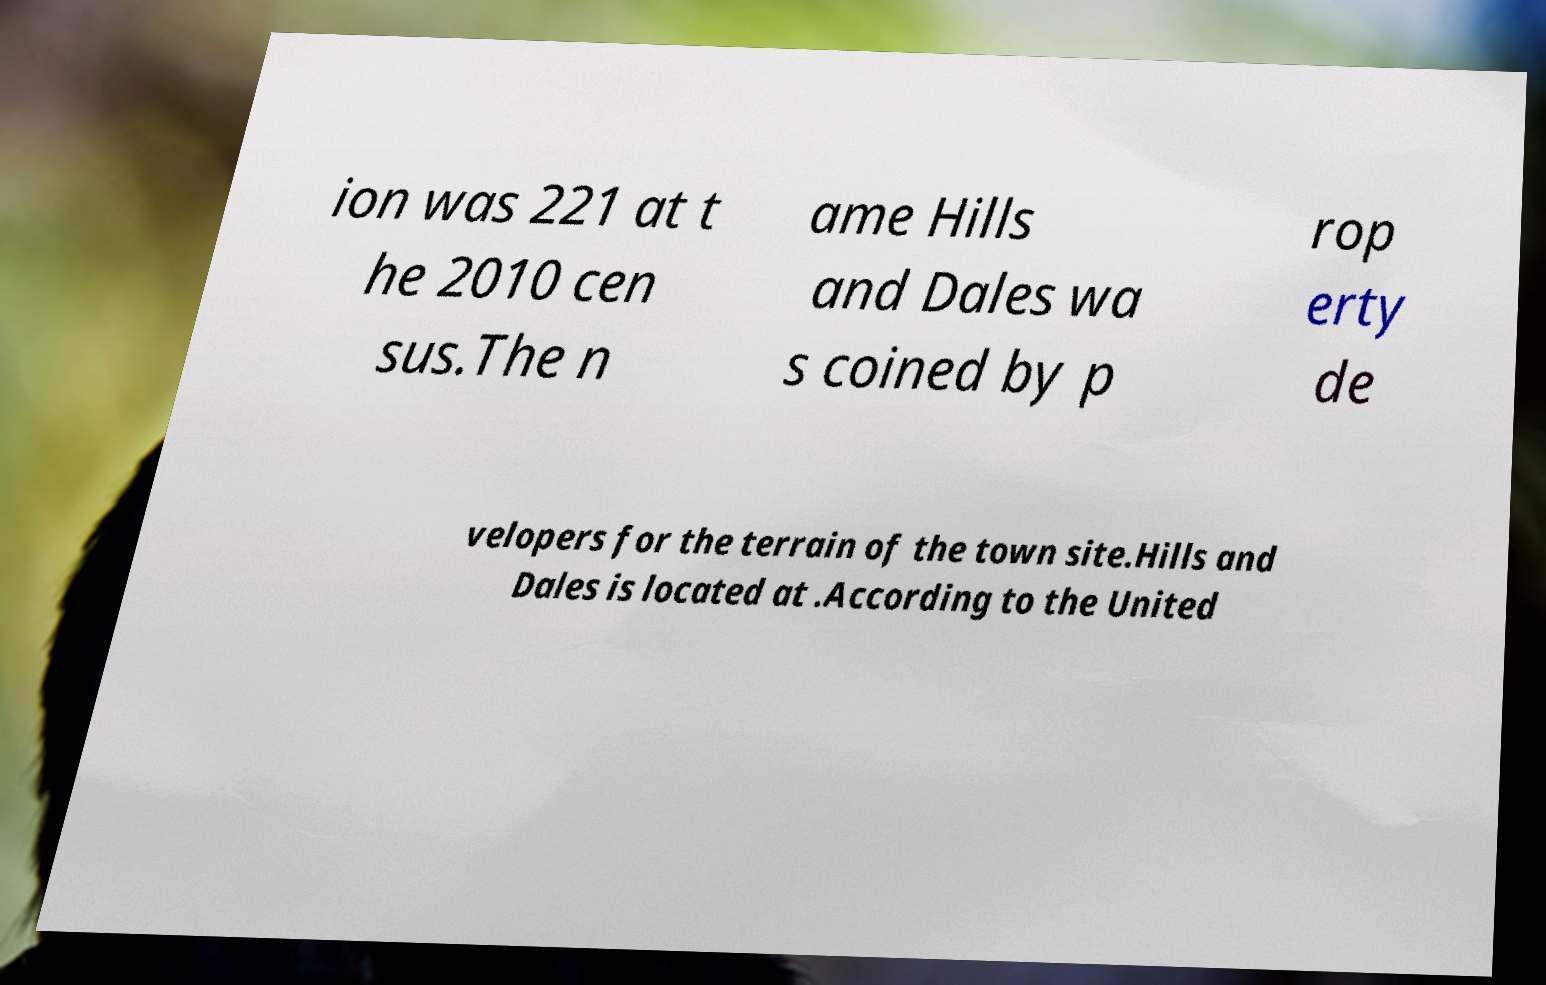Can you accurately transcribe the text from the provided image for me? ion was 221 at t he 2010 cen sus.The n ame Hills and Dales wa s coined by p rop erty de velopers for the terrain of the town site.Hills and Dales is located at .According to the United 